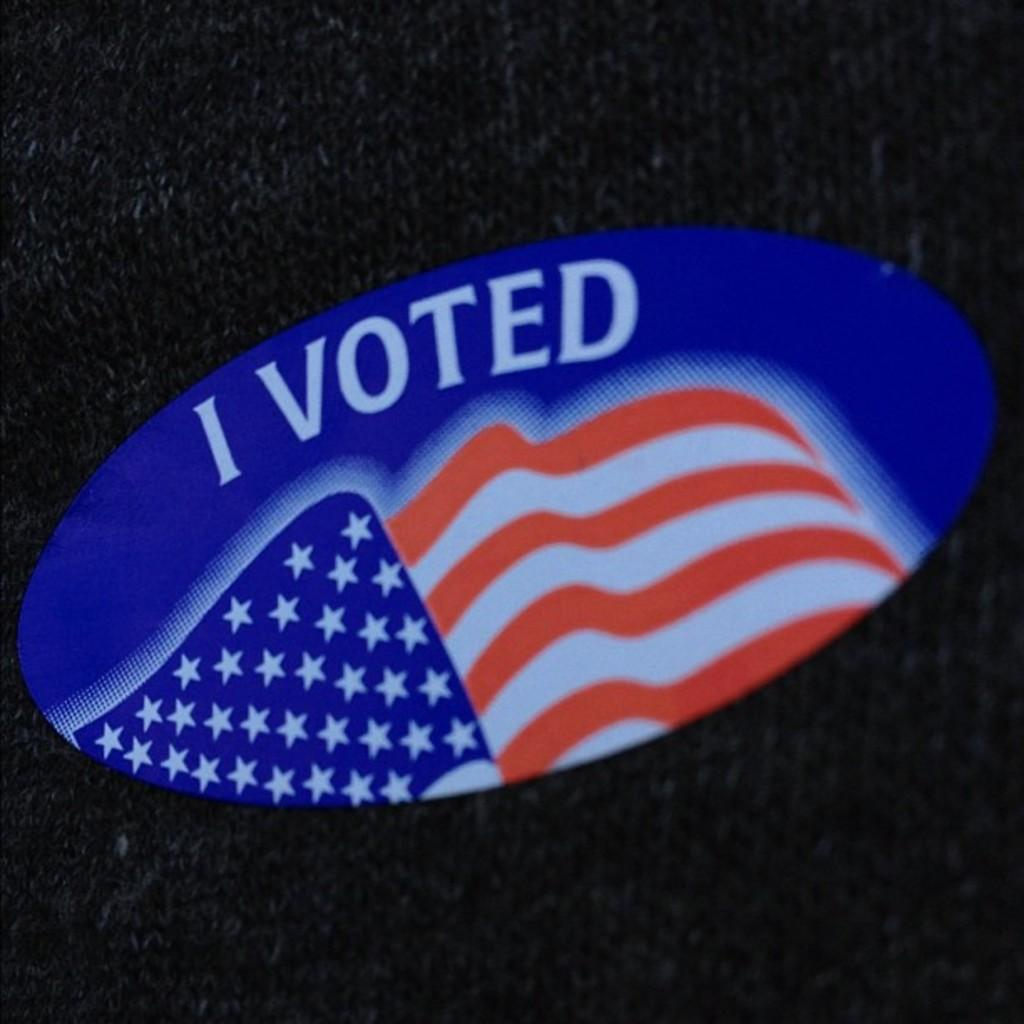What is the main subject in the center of the image? There is a lago in the center of the image. What is the name of the lago? The lago is named "I Voted." What type of vest is visible in the image? There is no vest present in the image. What is the engine used for in the image? There is no engine present in the image. 